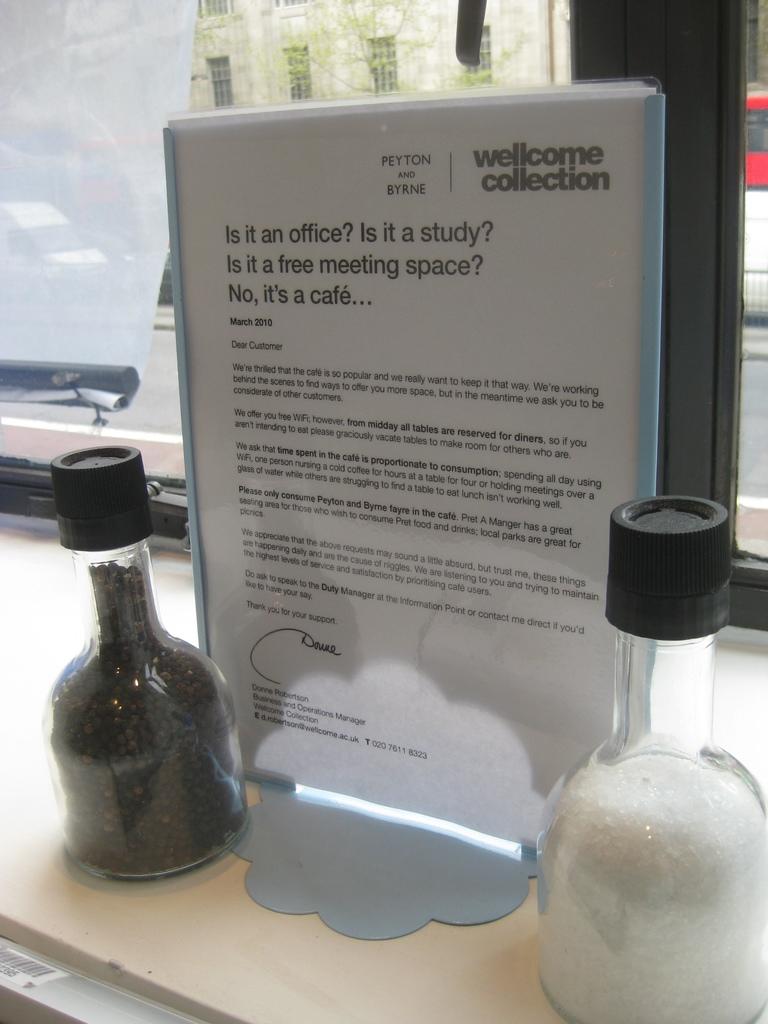What kind of establishment is the paper talking about?
Give a very brief answer. Cafe. What is the name of the collection?
Provide a short and direct response. Wellcome. 